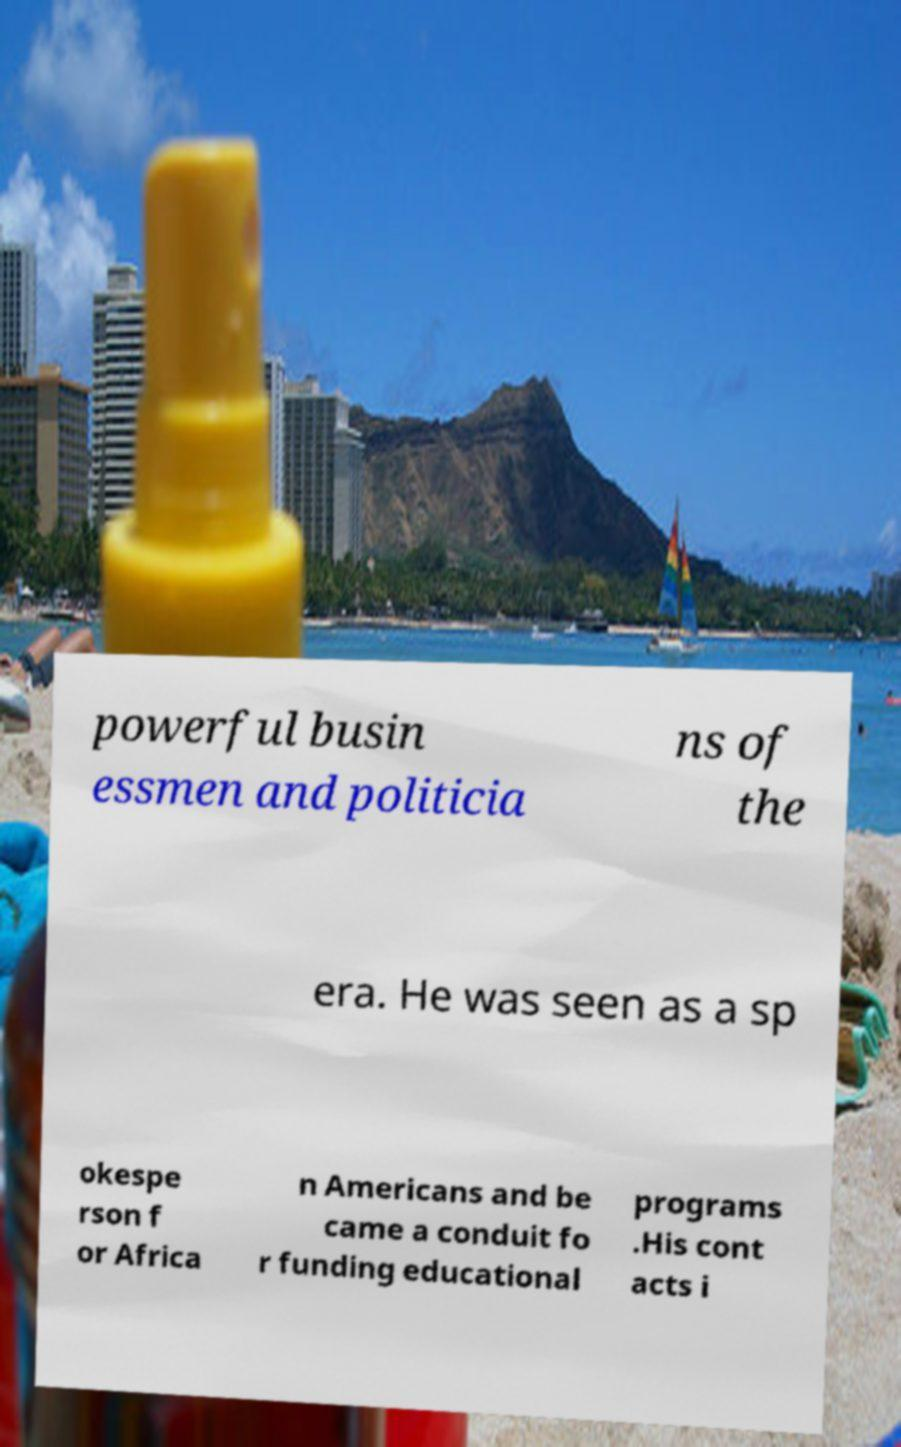For documentation purposes, I need the text within this image transcribed. Could you provide that? powerful busin essmen and politicia ns of the era. He was seen as a sp okespe rson f or Africa n Americans and be came a conduit fo r funding educational programs .His cont acts i 